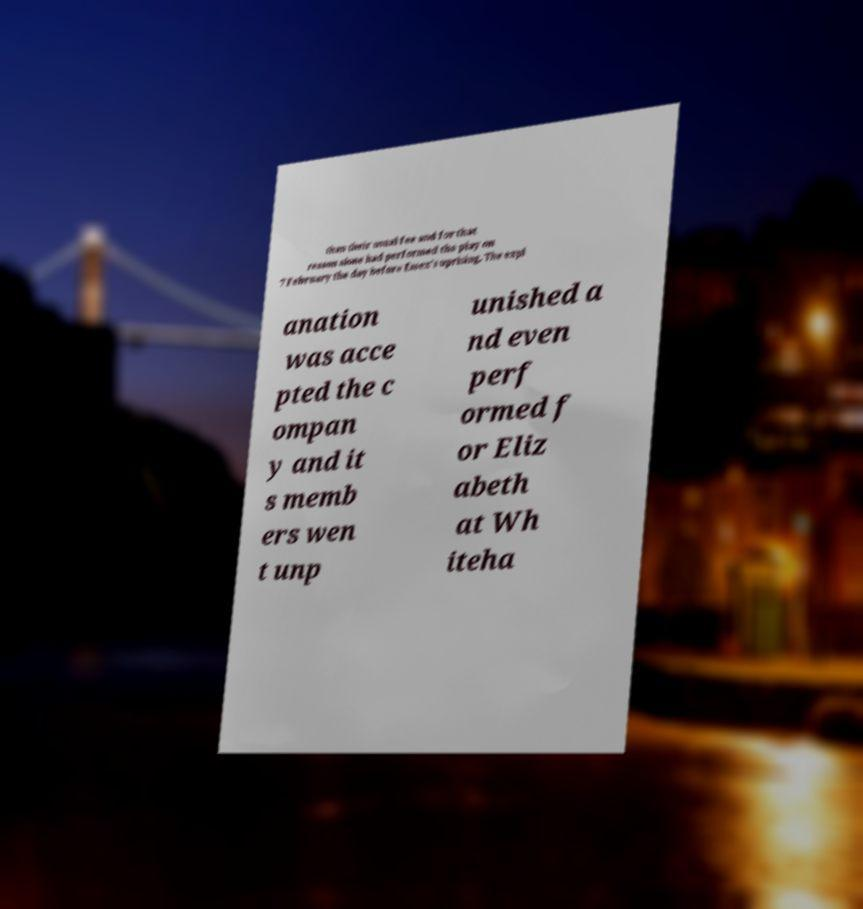Please identify and transcribe the text found in this image. than their usual fee and for that reason alone had performed the play on 7 February the day before Essex's uprising. The expl anation was acce pted the c ompan y and it s memb ers wen t unp unished a nd even perf ormed f or Eliz abeth at Wh iteha 